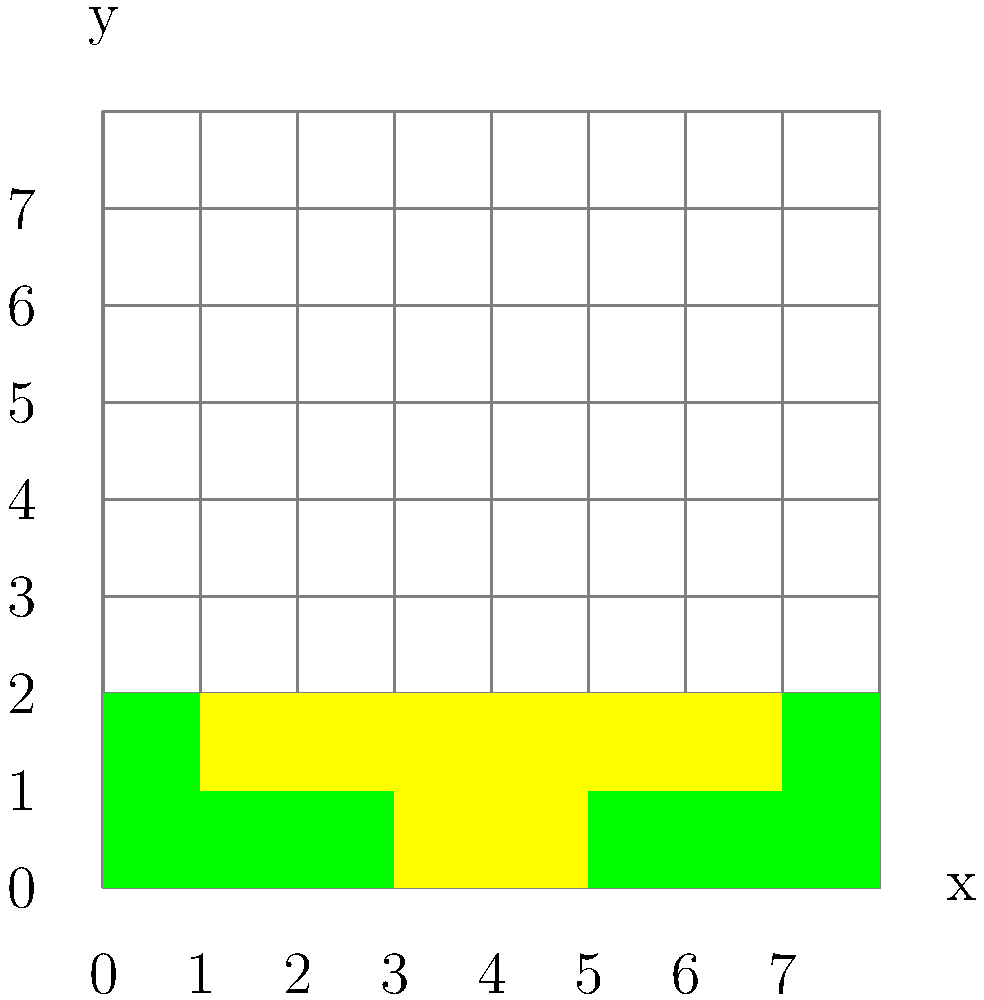In creating a pixel art avatar for a Green Bay Packers player, you've started with the helmet. The image shows the first two rows of pixels. How many pixels in total are colored yellow in these two rows? To determine the number of yellow pixels in the first two rows, let's count them step by step:

1. First row (y = 0):
   - There are 2 yellow pixels at x = 3 and x = 4.

2. Second row (y = 1):
   - There are 6 yellow pixels from x = 1 to x = 6.

3. Total yellow pixels:
   - First row: 2
   - Second row: 6
   - Sum: 2 + 6 = 8

Therefore, there are 8 yellow pixels in total in the first two rows of the Green Bay Packers player's helmet pixel art.
Answer: 8 